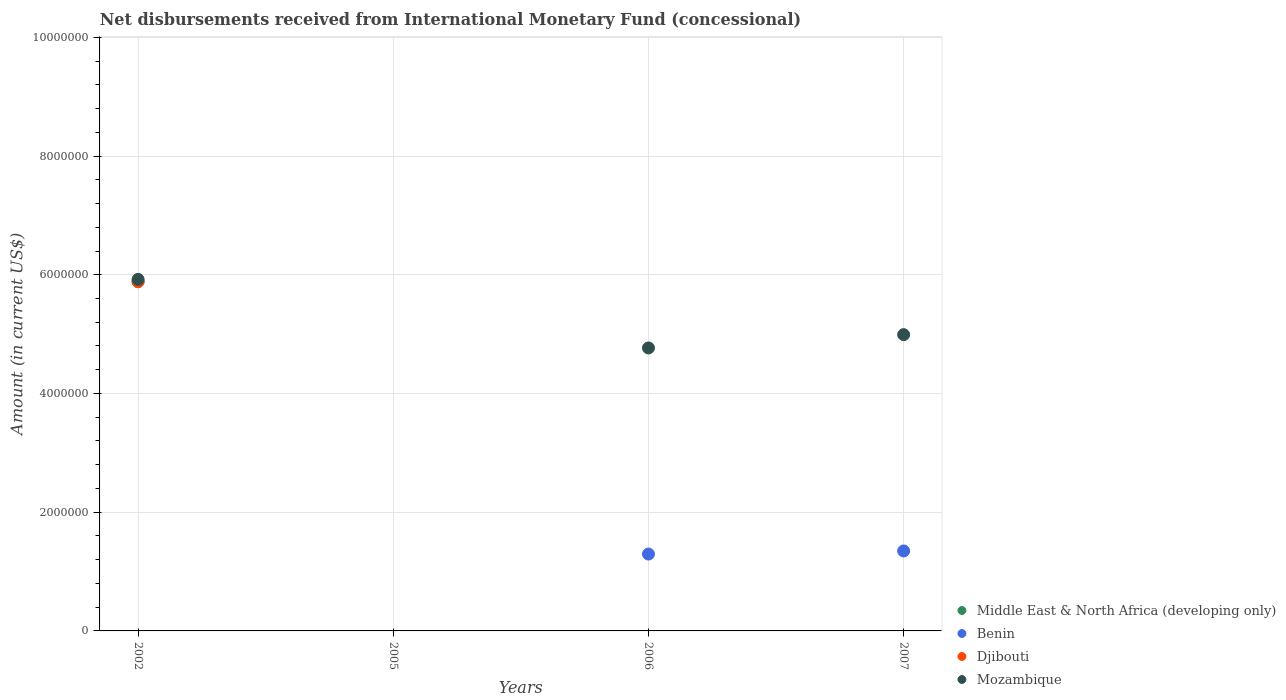How many different coloured dotlines are there?
Give a very brief answer. 4. Across all years, what is the maximum amount of disbursements received from International Monetary Fund in Middle East & North Africa (developing only)?
Your answer should be compact. 5.88e+06. Across all years, what is the minimum amount of disbursements received from International Monetary Fund in Djibouti?
Offer a terse response. 0. In which year was the amount of disbursements received from International Monetary Fund in Mozambique maximum?
Offer a terse response. 2002. What is the total amount of disbursements received from International Monetary Fund in Mozambique in the graph?
Give a very brief answer. 1.57e+07. What is the difference between the amount of disbursements received from International Monetary Fund in Benin in 2006 and that in 2007?
Make the answer very short. -5.20e+04. What is the average amount of disbursements received from International Monetary Fund in Mozambique per year?
Provide a succinct answer. 3.92e+06. In how many years, is the amount of disbursements received from International Monetary Fund in Middle East & North Africa (developing only) greater than 7200000 US$?
Your answer should be compact. 0. Is the amount of disbursements received from International Monetary Fund in Benin in 2006 less than that in 2007?
Keep it short and to the point. Yes. What is the difference between the highest and the second highest amount of disbursements received from International Monetary Fund in Mozambique?
Make the answer very short. 9.31e+05. What is the difference between the highest and the lowest amount of disbursements received from International Monetary Fund in Djibouti?
Your answer should be very brief. 5.88e+06. Is it the case that in every year, the sum of the amount of disbursements received from International Monetary Fund in Middle East & North Africa (developing only) and amount of disbursements received from International Monetary Fund in Mozambique  is greater than the amount of disbursements received from International Monetary Fund in Djibouti?
Ensure brevity in your answer.  No. Is the amount of disbursements received from International Monetary Fund in Djibouti strictly greater than the amount of disbursements received from International Monetary Fund in Middle East & North Africa (developing only) over the years?
Provide a succinct answer. No. Does the graph contain any zero values?
Ensure brevity in your answer.  Yes. How many legend labels are there?
Provide a succinct answer. 4. How are the legend labels stacked?
Provide a short and direct response. Vertical. What is the title of the graph?
Your response must be concise. Net disbursements received from International Monetary Fund (concessional). What is the Amount (in current US$) in Middle East & North Africa (developing only) in 2002?
Offer a very short reply. 5.88e+06. What is the Amount (in current US$) in Djibouti in 2002?
Your response must be concise. 5.88e+06. What is the Amount (in current US$) in Mozambique in 2002?
Provide a short and direct response. 5.92e+06. What is the Amount (in current US$) of Middle East & North Africa (developing only) in 2005?
Your answer should be very brief. 0. What is the Amount (in current US$) in Benin in 2005?
Your answer should be compact. 0. What is the Amount (in current US$) in Djibouti in 2005?
Keep it short and to the point. 0. What is the Amount (in current US$) in Middle East & North Africa (developing only) in 2006?
Offer a terse response. 0. What is the Amount (in current US$) in Benin in 2006?
Provide a short and direct response. 1.30e+06. What is the Amount (in current US$) of Mozambique in 2006?
Your answer should be very brief. 4.77e+06. What is the Amount (in current US$) of Middle East & North Africa (developing only) in 2007?
Offer a terse response. 0. What is the Amount (in current US$) in Benin in 2007?
Provide a succinct answer. 1.35e+06. What is the Amount (in current US$) of Djibouti in 2007?
Your response must be concise. 0. What is the Amount (in current US$) of Mozambique in 2007?
Provide a succinct answer. 4.99e+06. Across all years, what is the maximum Amount (in current US$) of Middle East & North Africa (developing only)?
Offer a very short reply. 5.88e+06. Across all years, what is the maximum Amount (in current US$) of Benin?
Give a very brief answer. 1.35e+06. Across all years, what is the maximum Amount (in current US$) of Djibouti?
Ensure brevity in your answer.  5.88e+06. Across all years, what is the maximum Amount (in current US$) of Mozambique?
Give a very brief answer. 5.92e+06. Across all years, what is the minimum Amount (in current US$) of Middle East & North Africa (developing only)?
Provide a short and direct response. 0. Across all years, what is the minimum Amount (in current US$) in Benin?
Provide a succinct answer. 0. What is the total Amount (in current US$) in Middle East & North Africa (developing only) in the graph?
Make the answer very short. 5.88e+06. What is the total Amount (in current US$) of Benin in the graph?
Keep it short and to the point. 2.64e+06. What is the total Amount (in current US$) in Djibouti in the graph?
Your answer should be compact. 5.88e+06. What is the total Amount (in current US$) of Mozambique in the graph?
Make the answer very short. 1.57e+07. What is the difference between the Amount (in current US$) of Mozambique in 2002 and that in 2006?
Keep it short and to the point. 1.16e+06. What is the difference between the Amount (in current US$) of Mozambique in 2002 and that in 2007?
Offer a very short reply. 9.31e+05. What is the difference between the Amount (in current US$) of Benin in 2006 and that in 2007?
Offer a terse response. -5.20e+04. What is the difference between the Amount (in current US$) in Mozambique in 2006 and that in 2007?
Give a very brief answer. -2.24e+05. What is the difference between the Amount (in current US$) in Middle East & North Africa (developing only) in 2002 and the Amount (in current US$) in Benin in 2006?
Your answer should be very brief. 4.59e+06. What is the difference between the Amount (in current US$) in Middle East & North Africa (developing only) in 2002 and the Amount (in current US$) in Mozambique in 2006?
Offer a terse response. 1.12e+06. What is the difference between the Amount (in current US$) in Djibouti in 2002 and the Amount (in current US$) in Mozambique in 2006?
Provide a short and direct response. 1.12e+06. What is the difference between the Amount (in current US$) of Middle East & North Africa (developing only) in 2002 and the Amount (in current US$) of Benin in 2007?
Keep it short and to the point. 4.54e+06. What is the difference between the Amount (in current US$) of Middle East & North Africa (developing only) in 2002 and the Amount (in current US$) of Mozambique in 2007?
Your answer should be very brief. 8.92e+05. What is the difference between the Amount (in current US$) of Djibouti in 2002 and the Amount (in current US$) of Mozambique in 2007?
Give a very brief answer. 8.92e+05. What is the difference between the Amount (in current US$) in Benin in 2006 and the Amount (in current US$) in Mozambique in 2007?
Give a very brief answer. -3.70e+06. What is the average Amount (in current US$) in Middle East & North Africa (developing only) per year?
Provide a succinct answer. 1.47e+06. What is the average Amount (in current US$) of Benin per year?
Ensure brevity in your answer.  6.60e+05. What is the average Amount (in current US$) of Djibouti per year?
Your answer should be very brief. 1.47e+06. What is the average Amount (in current US$) of Mozambique per year?
Make the answer very short. 3.92e+06. In the year 2002, what is the difference between the Amount (in current US$) in Middle East & North Africa (developing only) and Amount (in current US$) in Djibouti?
Your answer should be compact. 0. In the year 2002, what is the difference between the Amount (in current US$) in Middle East & North Africa (developing only) and Amount (in current US$) in Mozambique?
Ensure brevity in your answer.  -3.90e+04. In the year 2002, what is the difference between the Amount (in current US$) in Djibouti and Amount (in current US$) in Mozambique?
Ensure brevity in your answer.  -3.90e+04. In the year 2006, what is the difference between the Amount (in current US$) of Benin and Amount (in current US$) of Mozambique?
Make the answer very short. -3.47e+06. In the year 2007, what is the difference between the Amount (in current US$) in Benin and Amount (in current US$) in Mozambique?
Keep it short and to the point. -3.64e+06. What is the ratio of the Amount (in current US$) in Mozambique in 2002 to that in 2006?
Provide a succinct answer. 1.24. What is the ratio of the Amount (in current US$) in Mozambique in 2002 to that in 2007?
Your response must be concise. 1.19. What is the ratio of the Amount (in current US$) of Benin in 2006 to that in 2007?
Offer a terse response. 0.96. What is the ratio of the Amount (in current US$) in Mozambique in 2006 to that in 2007?
Offer a terse response. 0.96. What is the difference between the highest and the second highest Amount (in current US$) of Mozambique?
Your answer should be compact. 9.31e+05. What is the difference between the highest and the lowest Amount (in current US$) in Middle East & North Africa (developing only)?
Ensure brevity in your answer.  5.88e+06. What is the difference between the highest and the lowest Amount (in current US$) in Benin?
Give a very brief answer. 1.35e+06. What is the difference between the highest and the lowest Amount (in current US$) in Djibouti?
Ensure brevity in your answer.  5.88e+06. What is the difference between the highest and the lowest Amount (in current US$) in Mozambique?
Ensure brevity in your answer.  5.92e+06. 